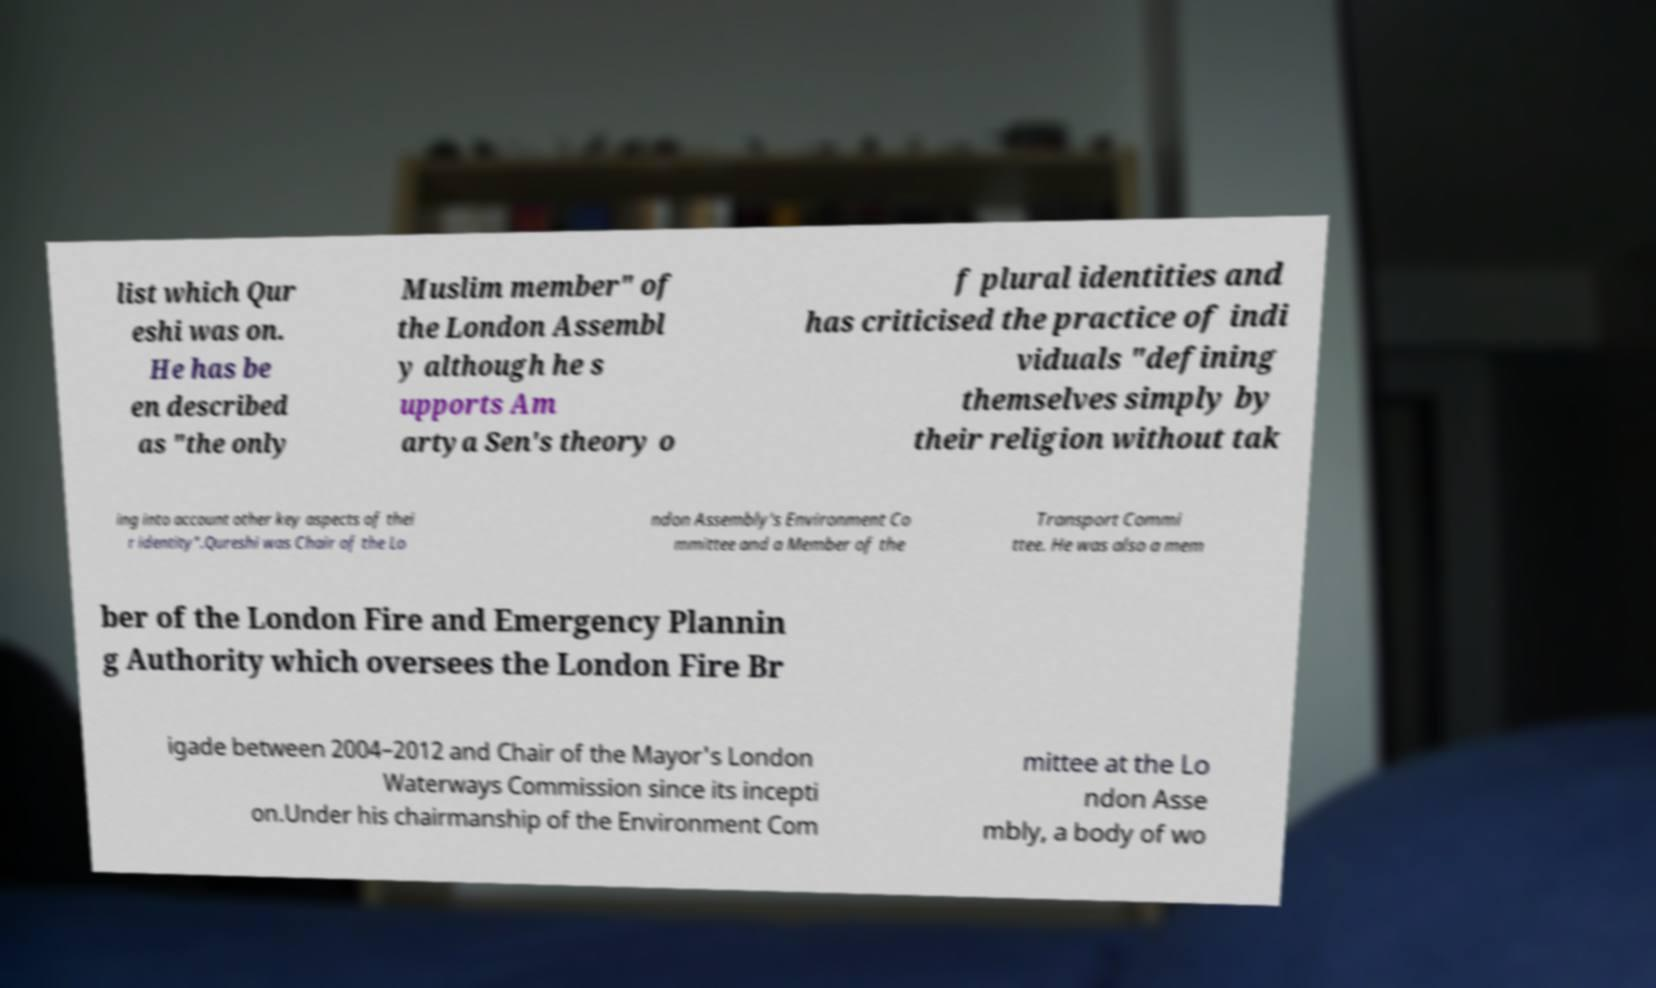For documentation purposes, I need the text within this image transcribed. Could you provide that? list which Qur eshi was on. He has be en described as "the only Muslim member" of the London Assembl y although he s upports Am artya Sen's theory o f plural identities and has criticised the practice of indi viduals "defining themselves simply by their religion without tak ing into account other key aspects of thei r identity".Qureshi was Chair of the Lo ndon Assembly's Environment Co mmittee and a Member of the Transport Commi ttee. He was also a mem ber of the London Fire and Emergency Plannin g Authority which oversees the London Fire Br igade between 2004–2012 and Chair of the Mayor's London Waterways Commission since its incepti on.Under his chairmanship of the Environment Com mittee at the Lo ndon Asse mbly, a body of wo 